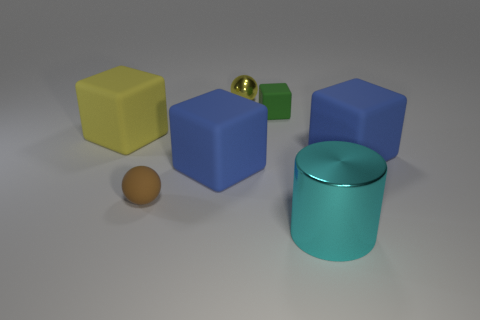There is a large matte object that is to the right of the big cyan object; is it the same color as the big metallic cylinder?
Provide a short and direct response. No. There is a small ball that is made of the same material as the yellow block; what color is it?
Keep it short and to the point. Brown. Do the brown rubber sphere and the metal ball have the same size?
Ensure brevity in your answer.  Yes. What is the small yellow thing made of?
Provide a short and direct response. Metal. There is a cyan cylinder that is the same size as the yellow block; what is its material?
Provide a succinct answer. Metal. Are there any purple spheres of the same size as the green thing?
Provide a succinct answer. No. Are there an equal number of yellow matte objects on the right side of the small brown object and shiny balls that are in front of the small green object?
Your response must be concise. Yes. Is the number of blue objects greater than the number of small matte cubes?
Your response must be concise. Yes. What number of matte objects are either big cyan things or big blue things?
Keep it short and to the point. 2. How many other big metal things are the same color as the large metallic thing?
Keep it short and to the point. 0. 